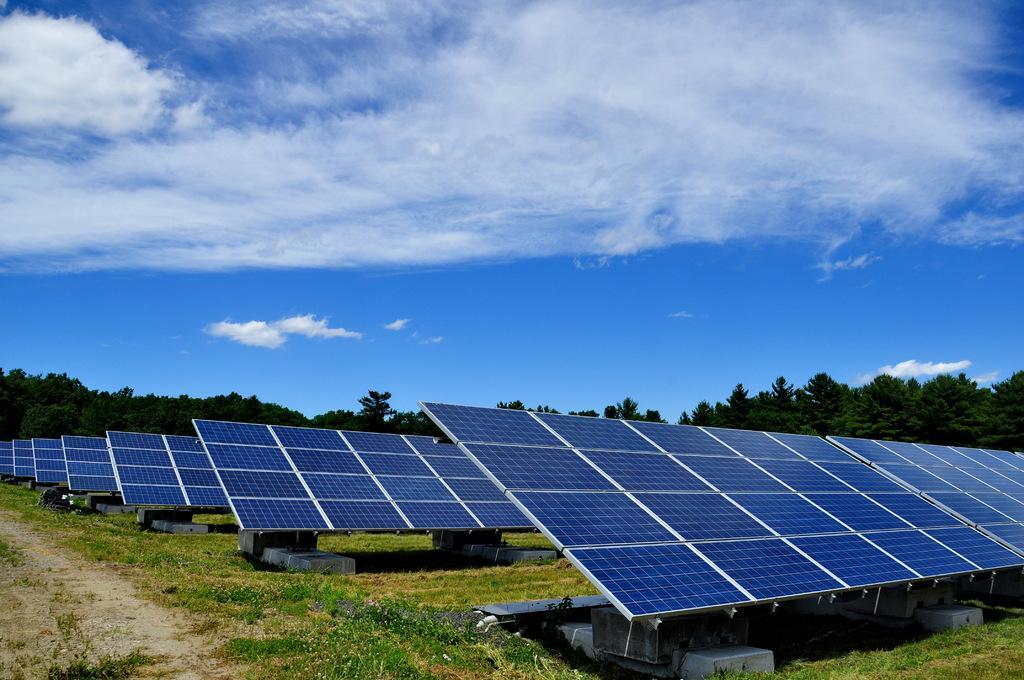How would you summarize this image in a sentence or two? In this image there are some boards like objects, and at the bottom there is grass and walkway. And in the background there are trees, at the top there is sky. 